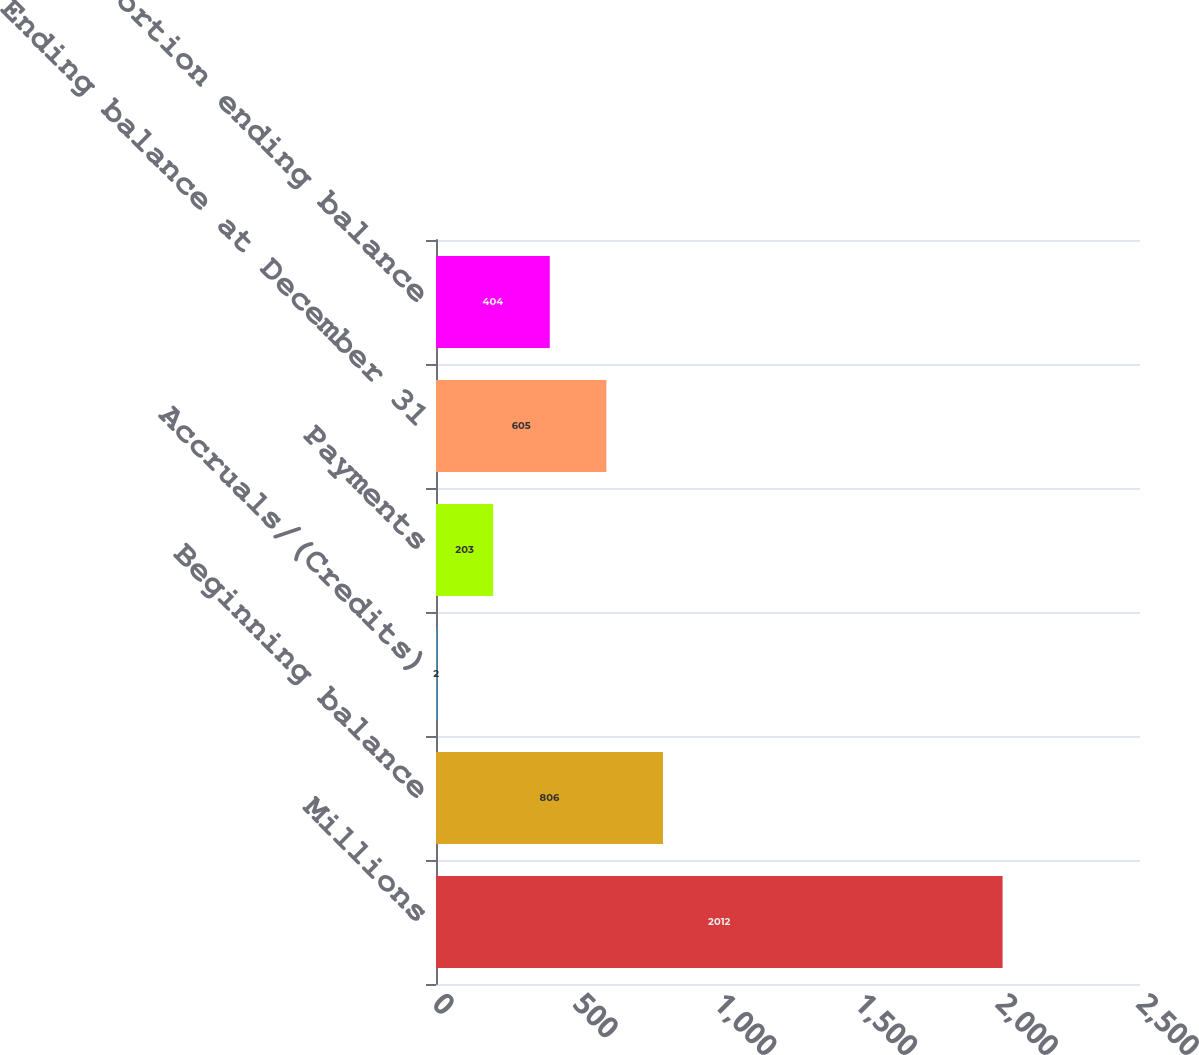<chart> <loc_0><loc_0><loc_500><loc_500><bar_chart><fcel>Millions<fcel>Beginning balance<fcel>Accruals/(Credits)<fcel>Payments<fcel>Ending balance at December 31<fcel>Current portion ending balance<nl><fcel>2012<fcel>806<fcel>2<fcel>203<fcel>605<fcel>404<nl></chart> 